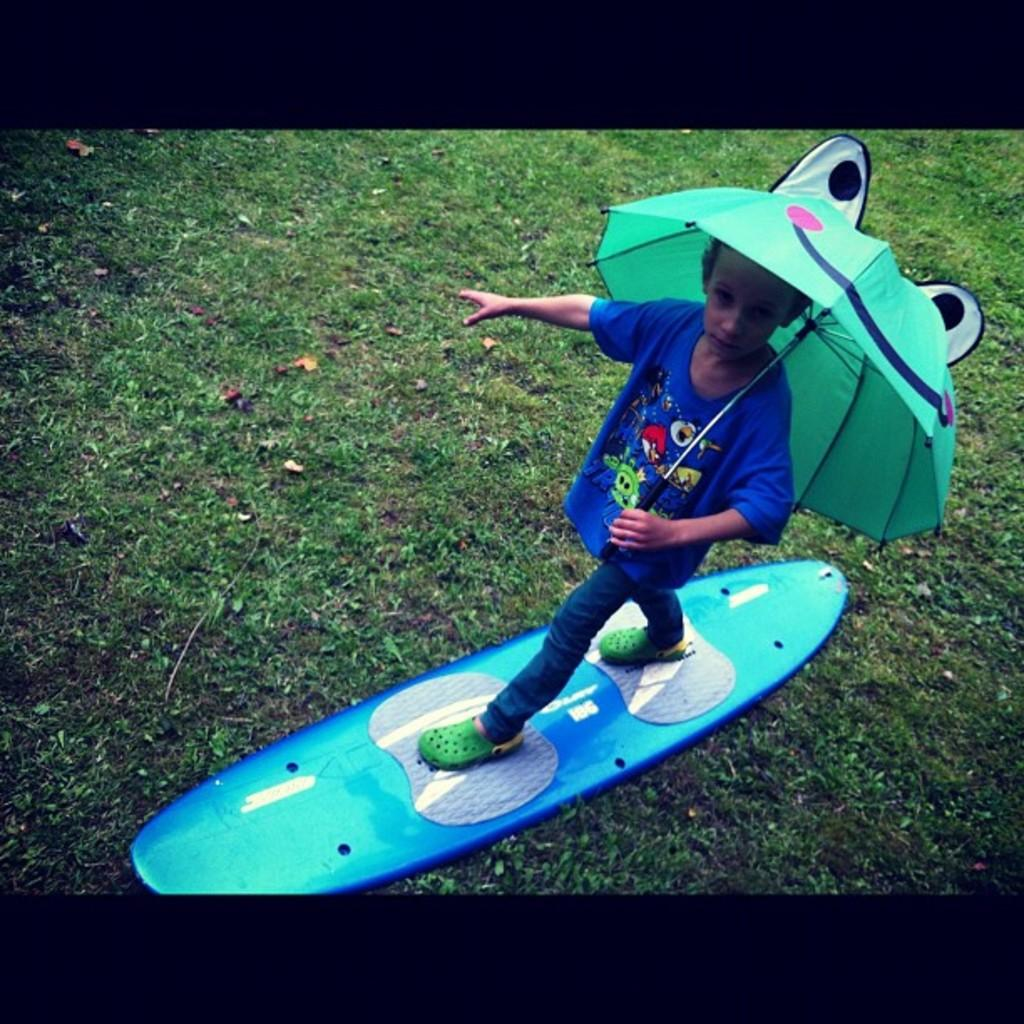Who is the main subject in the image? There is a boy in the image. What is the boy doing in the image? The boy is standing on a surfing board. What object is the boy holding in the image? The boy is holding an umbrella. What type of terrain is visible at the bottom of the image? There is grass at the bottom of the image. Where can the quince be found in the image? There is no quince present in the image. What type of wheel is attached to the surfing board in the image? The image does not show any wheels attached to the surfing board. 